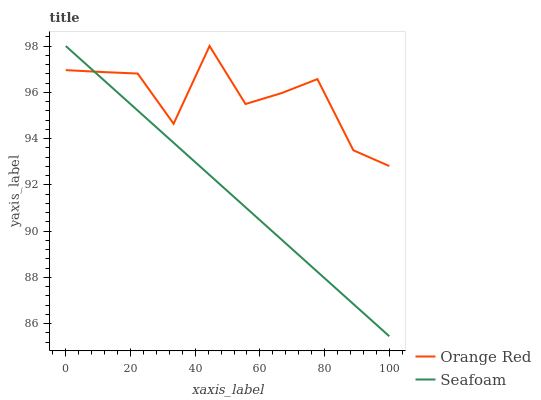Does Seafoam have the minimum area under the curve?
Answer yes or no. Yes. Does Orange Red have the maximum area under the curve?
Answer yes or no. Yes. Does Seafoam have the maximum area under the curve?
Answer yes or no. No. Is Seafoam the smoothest?
Answer yes or no. Yes. Is Orange Red the roughest?
Answer yes or no. Yes. Is Seafoam the roughest?
Answer yes or no. No. Does Seafoam have the highest value?
Answer yes or no. Yes. 